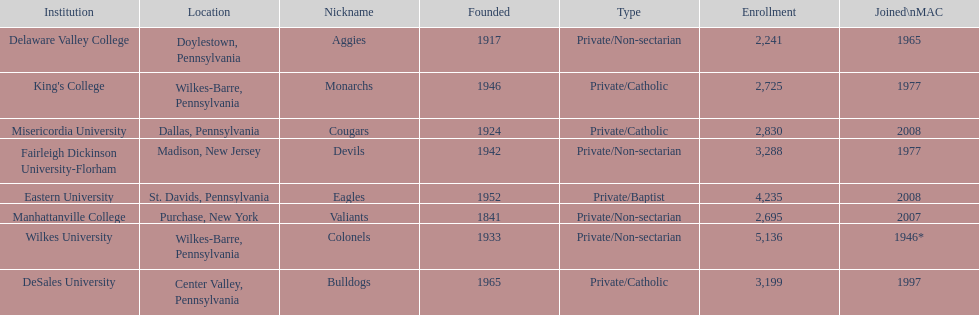How many are enrolled in private/catholic? 8,754. 